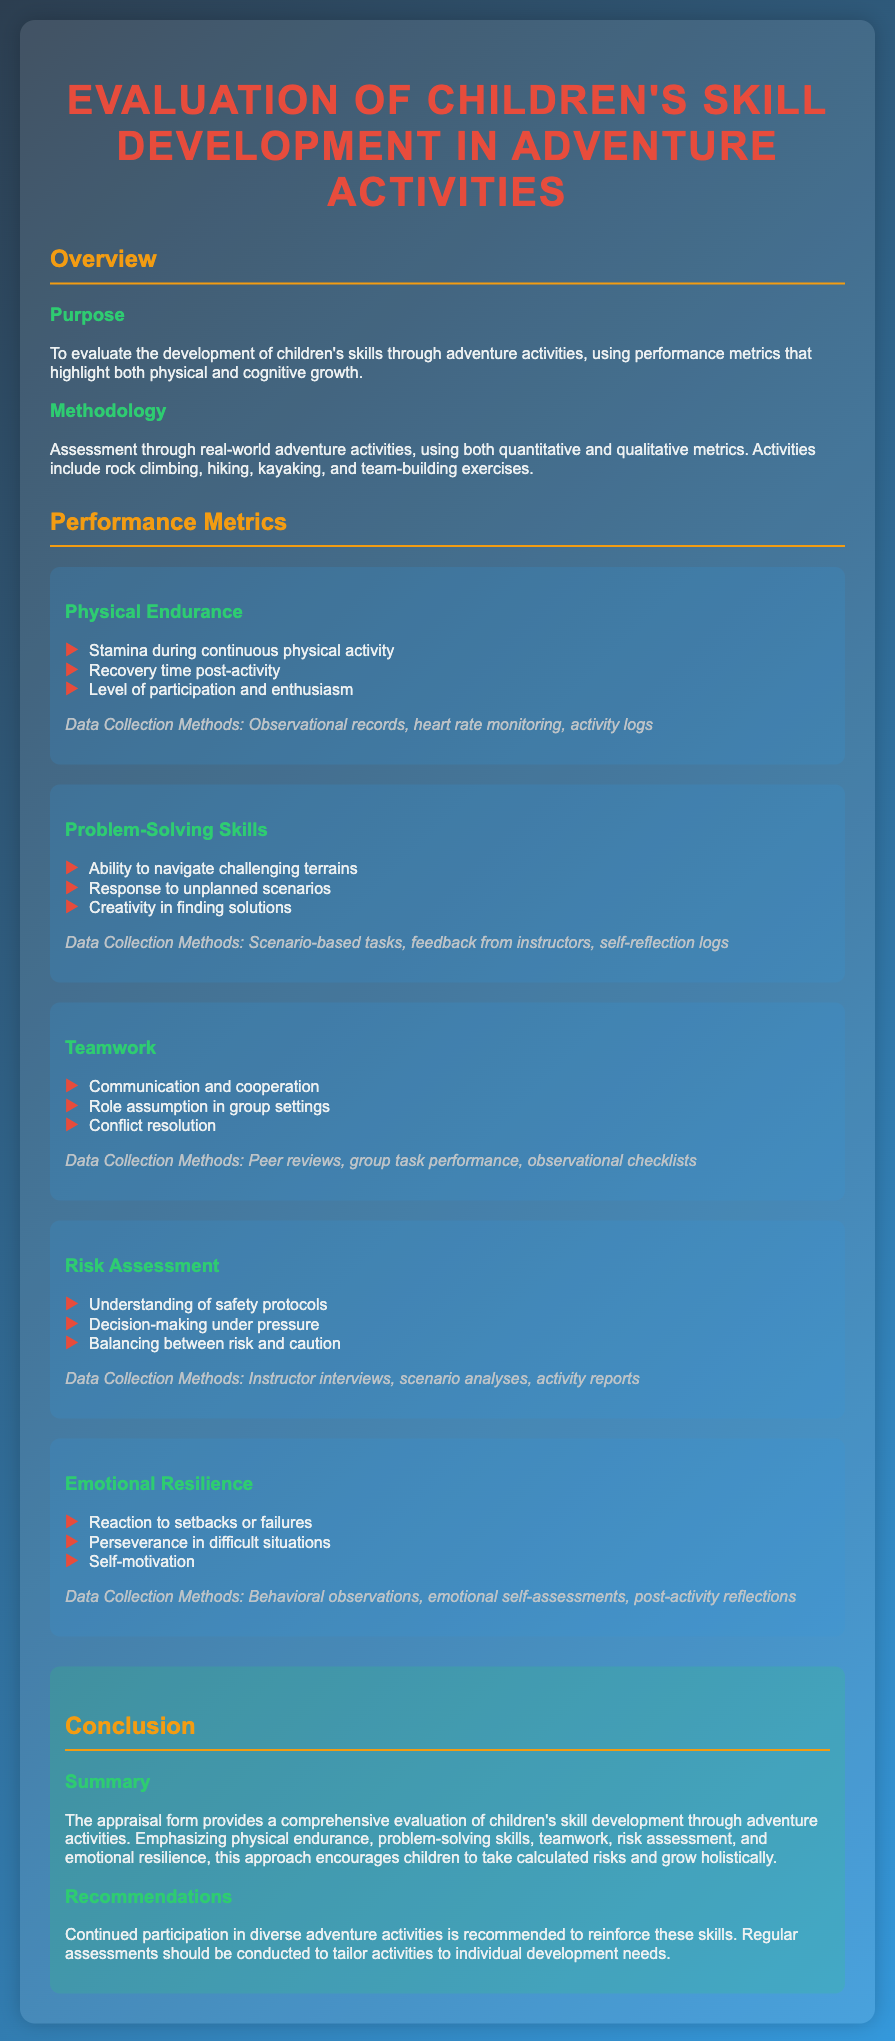What is the title of the document? The title is the heading of the document that encapsulates the main focus of the evaluation.
Answer: Evaluation of Children's Skill Development in Adventure Activities What activities are assessed in this document? The document lists the specific adventure activities used for assessment.
Answer: Rock climbing, hiking, kayaking, and team-building exercises What physical metric is focused on regarding children's skill development? This is a specific metric mentioned in the section regarding performance metrics.
Answer: Physical Endurance What type of data collection method is used for problem-solving skills? This question seeks the methods stated for collecting data on problem-solving skills in children.
Answer: Scenario-based tasks, feedback from instructors, self-reflection logs Which aspect involves understanding safety protocols? This is a specific area mentioned under one of the performance metrics related to risk management.
Answer: Risk Assessment What is emphasized in the “Conclusion” section? This question targets the main focus stated in the conclusion about the skills being assessed.
Answer: Holistic growth How many performance metrics are listed in the document? The total number of performance metrics provided reflects the areas assessed.
Answer: Five What recommendation is given in the conclusion? This question addresses the suggestions made for continued engagement in activities.
Answer: Continued participation in diverse adventure activities 